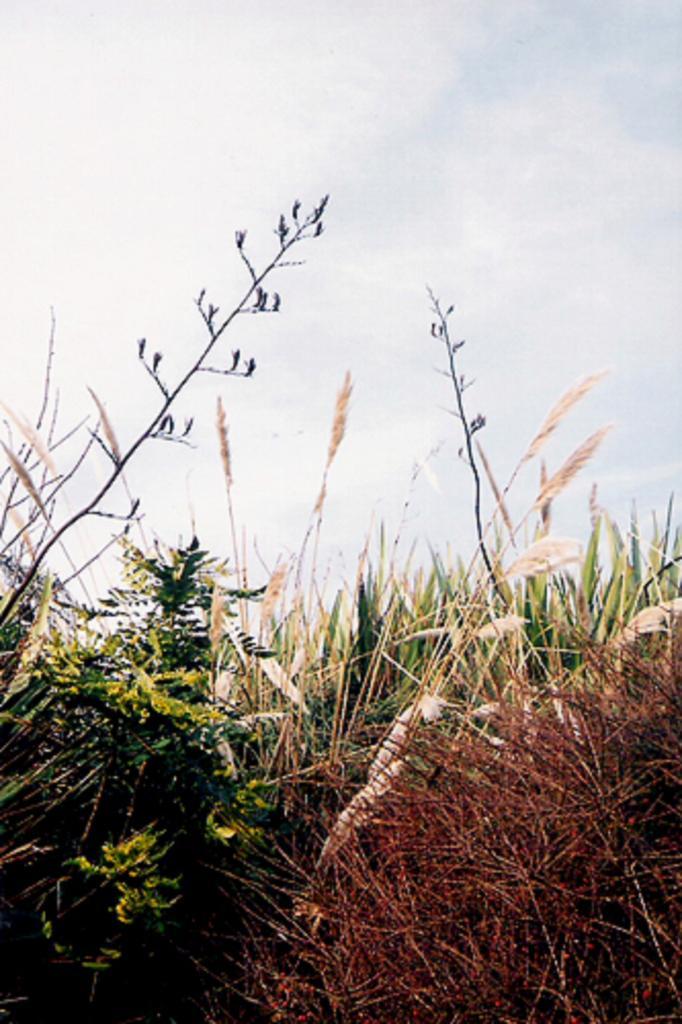How would you summarize this image in a sentence or two? In this image there are plants, in the background there is the sky. 